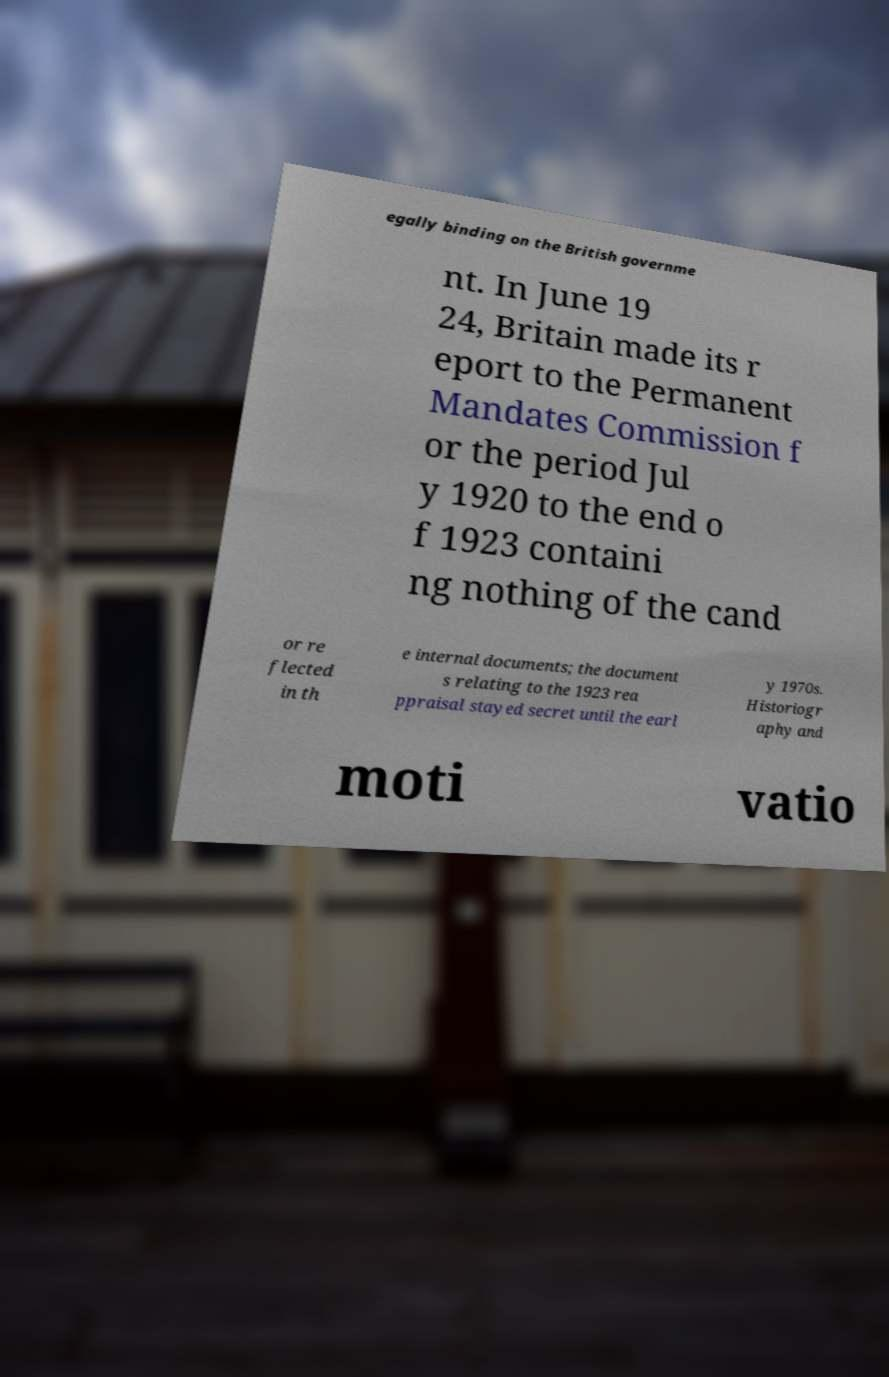There's text embedded in this image that I need extracted. Can you transcribe it verbatim? egally binding on the British governme nt. In June 19 24, Britain made its r eport to the Permanent Mandates Commission f or the period Jul y 1920 to the end o f 1923 containi ng nothing of the cand or re flected in th e internal documents; the document s relating to the 1923 rea ppraisal stayed secret until the earl y 1970s. Historiogr aphy and moti vatio 